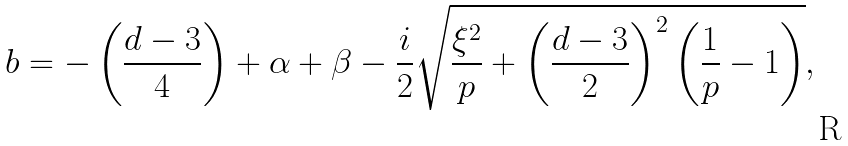<formula> <loc_0><loc_0><loc_500><loc_500>b = - \left ( \frac { d - 3 } { 4 } \right ) + \alpha + \beta - \frac { i } { 2 } \sqrt { \frac { \xi ^ { 2 } } { p } + \left ( \frac { d - 3 } { 2 } \right ) ^ { 2 } \left ( \frac { 1 } { p } - 1 \right ) } ,</formula> 